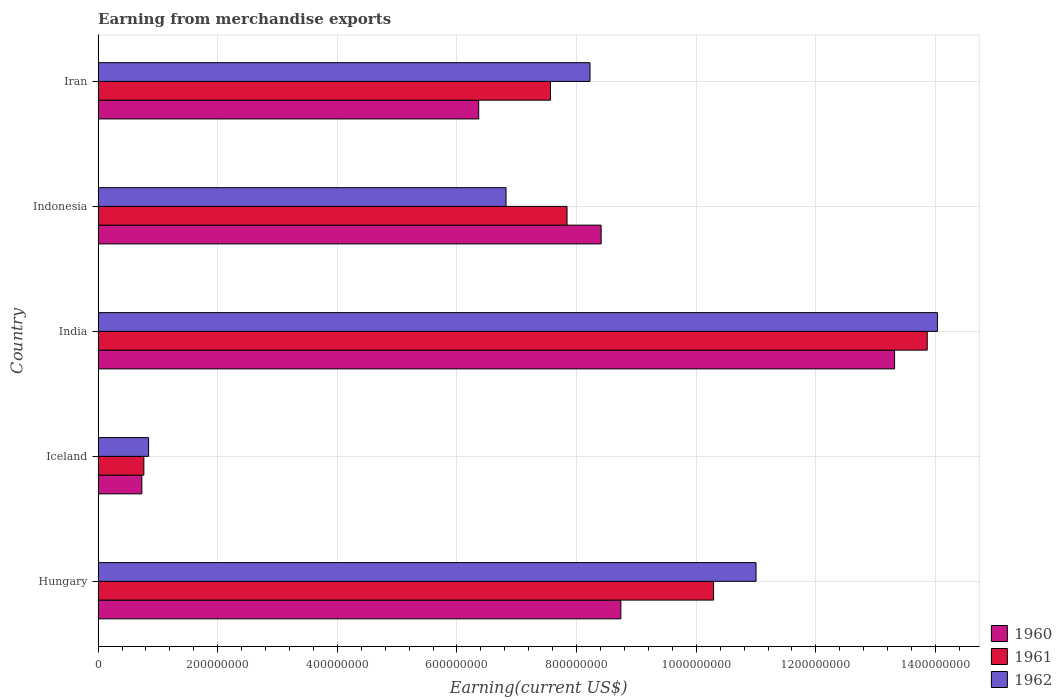Are the number of bars per tick equal to the number of legend labels?
Provide a short and direct response. Yes. How many bars are there on the 1st tick from the top?
Your answer should be very brief. 3. How many bars are there on the 5th tick from the bottom?
Provide a succinct answer. 3. What is the label of the 2nd group of bars from the top?
Your answer should be very brief. Indonesia. In how many cases, is the number of bars for a given country not equal to the number of legend labels?
Keep it short and to the point. 0. What is the amount earned from merchandise exports in 1962 in Hungary?
Your answer should be very brief. 1.10e+09. Across all countries, what is the maximum amount earned from merchandise exports in 1961?
Your response must be concise. 1.39e+09. Across all countries, what is the minimum amount earned from merchandise exports in 1960?
Provide a succinct answer. 7.31e+07. In which country was the amount earned from merchandise exports in 1961 maximum?
Your answer should be very brief. India. In which country was the amount earned from merchandise exports in 1961 minimum?
Give a very brief answer. Iceland. What is the total amount earned from merchandise exports in 1960 in the graph?
Keep it short and to the point. 3.76e+09. What is the difference between the amount earned from merchandise exports in 1961 in India and that in Iran?
Ensure brevity in your answer.  6.30e+08. What is the difference between the amount earned from merchandise exports in 1960 in Indonesia and the amount earned from merchandise exports in 1961 in Hungary?
Your response must be concise. -1.88e+08. What is the average amount earned from merchandise exports in 1961 per country?
Make the answer very short. 8.06e+08. What is the difference between the amount earned from merchandise exports in 1962 and amount earned from merchandise exports in 1960 in Iran?
Ensure brevity in your answer.  1.86e+08. What is the ratio of the amount earned from merchandise exports in 1962 in India to that in Indonesia?
Your answer should be compact. 2.06. What is the difference between the highest and the second highest amount earned from merchandise exports in 1960?
Your response must be concise. 4.58e+08. What is the difference between the highest and the lowest amount earned from merchandise exports in 1960?
Offer a very short reply. 1.26e+09. In how many countries, is the amount earned from merchandise exports in 1961 greater than the average amount earned from merchandise exports in 1961 taken over all countries?
Your answer should be compact. 2. Is the sum of the amount earned from merchandise exports in 1961 in Iceland and India greater than the maximum amount earned from merchandise exports in 1962 across all countries?
Provide a short and direct response. Yes. How many bars are there?
Your response must be concise. 15. Are all the bars in the graph horizontal?
Make the answer very short. Yes. How many countries are there in the graph?
Provide a short and direct response. 5. What is the difference between two consecutive major ticks on the X-axis?
Offer a terse response. 2.00e+08. Are the values on the major ticks of X-axis written in scientific E-notation?
Your answer should be compact. No. Does the graph contain grids?
Your answer should be very brief. Yes. Where does the legend appear in the graph?
Make the answer very short. Bottom right. How are the legend labels stacked?
Ensure brevity in your answer.  Vertical. What is the title of the graph?
Your answer should be compact. Earning from merchandise exports. What is the label or title of the X-axis?
Your response must be concise. Earning(current US$). What is the label or title of the Y-axis?
Offer a terse response. Country. What is the Earning(current US$) in 1960 in Hungary?
Provide a short and direct response. 8.74e+08. What is the Earning(current US$) of 1961 in Hungary?
Your answer should be very brief. 1.03e+09. What is the Earning(current US$) in 1962 in Hungary?
Provide a short and direct response. 1.10e+09. What is the Earning(current US$) of 1960 in Iceland?
Offer a very short reply. 7.31e+07. What is the Earning(current US$) in 1961 in Iceland?
Provide a succinct answer. 7.65e+07. What is the Earning(current US$) in 1962 in Iceland?
Offer a terse response. 8.44e+07. What is the Earning(current US$) of 1960 in India?
Ensure brevity in your answer.  1.33e+09. What is the Earning(current US$) of 1961 in India?
Your answer should be very brief. 1.39e+09. What is the Earning(current US$) in 1962 in India?
Offer a very short reply. 1.40e+09. What is the Earning(current US$) of 1960 in Indonesia?
Provide a succinct answer. 8.41e+08. What is the Earning(current US$) in 1961 in Indonesia?
Provide a succinct answer. 7.84e+08. What is the Earning(current US$) of 1962 in Indonesia?
Give a very brief answer. 6.82e+08. What is the Earning(current US$) of 1960 in Iran?
Offer a terse response. 6.36e+08. What is the Earning(current US$) in 1961 in Iran?
Ensure brevity in your answer.  7.56e+08. What is the Earning(current US$) of 1962 in Iran?
Your answer should be very brief. 8.22e+08. Across all countries, what is the maximum Earning(current US$) of 1960?
Provide a succinct answer. 1.33e+09. Across all countries, what is the maximum Earning(current US$) of 1961?
Ensure brevity in your answer.  1.39e+09. Across all countries, what is the maximum Earning(current US$) of 1962?
Offer a very short reply. 1.40e+09. Across all countries, what is the minimum Earning(current US$) in 1960?
Your answer should be compact. 7.31e+07. Across all countries, what is the minimum Earning(current US$) of 1961?
Make the answer very short. 7.65e+07. Across all countries, what is the minimum Earning(current US$) of 1962?
Your response must be concise. 8.44e+07. What is the total Earning(current US$) in 1960 in the graph?
Offer a terse response. 3.76e+09. What is the total Earning(current US$) in 1961 in the graph?
Your response must be concise. 4.03e+09. What is the total Earning(current US$) of 1962 in the graph?
Your answer should be compact. 4.09e+09. What is the difference between the Earning(current US$) in 1960 in Hungary and that in Iceland?
Offer a terse response. 8.01e+08. What is the difference between the Earning(current US$) in 1961 in Hungary and that in Iceland?
Keep it short and to the point. 9.53e+08. What is the difference between the Earning(current US$) in 1962 in Hungary and that in Iceland?
Keep it short and to the point. 1.02e+09. What is the difference between the Earning(current US$) in 1960 in Hungary and that in India?
Provide a short and direct response. -4.58e+08. What is the difference between the Earning(current US$) of 1961 in Hungary and that in India?
Provide a short and direct response. -3.57e+08. What is the difference between the Earning(current US$) in 1962 in Hungary and that in India?
Give a very brief answer. -3.03e+08. What is the difference between the Earning(current US$) of 1960 in Hungary and that in Indonesia?
Keep it short and to the point. 3.30e+07. What is the difference between the Earning(current US$) of 1961 in Hungary and that in Indonesia?
Your response must be concise. 2.45e+08. What is the difference between the Earning(current US$) in 1962 in Hungary and that in Indonesia?
Make the answer very short. 4.18e+08. What is the difference between the Earning(current US$) in 1960 in Hungary and that in Iran?
Offer a terse response. 2.38e+08. What is the difference between the Earning(current US$) of 1961 in Hungary and that in Iran?
Provide a succinct answer. 2.73e+08. What is the difference between the Earning(current US$) of 1962 in Hungary and that in Iran?
Give a very brief answer. 2.78e+08. What is the difference between the Earning(current US$) in 1960 in Iceland and that in India?
Provide a succinct answer. -1.26e+09. What is the difference between the Earning(current US$) in 1961 in Iceland and that in India?
Ensure brevity in your answer.  -1.31e+09. What is the difference between the Earning(current US$) in 1962 in Iceland and that in India?
Your answer should be very brief. -1.32e+09. What is the difference between the Earning(current US$) in 1960 in Iceland and that in Indonesia?
Make the answer very short. -7.68e+08. What is the difference between the Earning(current US$) in 1961 in Iceland and that in Indonesia?
Provide a short and direct response. -7.08e+08. What is the difference between the Earning(current US$) in 1962 in Iceland and that in Indonesia?
Give a very brief answer. -5.98e+08. What is the difference between the Earning(current US$) of 1960 in Iceland and that in Iran?
Give a very brief answer. -5.63e+08. What is the difference between the Earning(current US$) of 1961 in Iceland and that in Iran?
Offer a very short reply. -6.80e+08. What is the difference between the Earning(current US$) of 1962 in Iceland and that in Iran?
Ensure brevity in your answer.  -7.38e+08. What is the difference between the Earning(current US$) in 1960 in India and that in Indonesia?
Your answer should be very brief. 4.91e+08. What is the difference between the Earning(current US$) of 1961 in India and that in Indonesia?
Keep it short and to the point. 6.02e+08. What is the difference between the Earning(current US$) of 1962 in India and that in Indonesia?
Provide a short and direct response. 7.21e+08. What is the difference between the Earning(current US$) of 1960 in India and that in Iran?
Provide a short and direct response. 6.95e+08. What is the difference between the Earning(current US$) of 1961 in India and that in Iran?
Your answer should be compact. 6.30e+08. What is the difference between the Earning(current US$) of 1962 in India and that in Iran?
Keep it short and to the point. 5.81e+08. What is the difference between the Earning(current US$) of 1960 in Indonesia and that in Iran?
Ensure brevity in your answer.  2.05e+08. What is the difference between the Earning(current US$) in 1961 in Indonesia and that in Iran?
Your answer should be very brief. 2.77e+07. What is the difference between the Earning(current US$) of 1962 in Indonesia and that in Iran?
Offer a terse response. -1.40e+08. What is the difference between the Earning(current US$) of 1960 in Hungary and the Earning(current US$) of 1961 in Iceland?
Your answer should be very brief. 7.98e+08. What is the difference between the Earning(current US$) in 1960 in Hungary and the Earning(current US$) in 1962 in Iceland?
Provide a short and direct response. 7.90e+08. What is the difference between the Earning(current US$) in 1961 in Hungary and the Earning(current US$) in 1962 in Iceland?
Offer a terse response. 9.45e+08. What is the difference between the Earning(current US$) of 1960 in Hungary and the Earning(current US$) of 1961 in India?
Give a very brief answer. -5.12e+08. What is the difference between the Earning(current US$) in 1960 in Hungary and the Earning(current US$) in 1962 in India?
Your answer should be very brief. -5.29e+08. What is the difference between the Earning(current US$) of 1961 in Hungary and the Earning(current US$) of 1962 in India?
Offer a very short reply. -3.74e+08. What is the difference between the Earning(current US$) of 1960 in Hungary and the Earning(current US$) of 1961 in Indonesia?
Give a very brief answer. 9.00e+07. What is the difference between the Earning(current US$) of 1960 in Hungary and the Earning(current US$) of 1962 in Indonesia?
Provide a short and direct response. 1.92e+08. What is the difference between the Earning(current US$) in 1961 in Hungary and the Earning(current US$) in 1962 in Indonesia?
Offer a very short reply. 3.47e+08. What is the difference between the Earning(current US$) of 1960 in Hungary and the Earning(current US$) of 1961 in Iran?
Give a very brief answer. 1.18e+08. What is the difference between the Earning(current US$) of 1960 in Hungary and the Earning(current US$) of 1962 in Iran?
Keep it short and to the point. 5.16e+07. What is the difference between the Earning(current US$) of 1961 in Hungary and the Earning(current US$) of 1962 in Iran?
Offer a terse response. 2.07e+08. What is the difference between the Earning(current US$) of 1960 in Iceland and the Earning(current US$) of 1961 in India?
Your answer should be compact. -1.31e+09. What is the difference between the Earning(current US$) in 1960 in Iceland and the Earning(current US$) in 1962 in India?
Your response must be concise. -1.33e+09. What is the difference between the Earning(current US$) of 1961 in Iceland and the Earning(current US$) of 1962 in India?
Offer a very short reply. -1.33e+09. What is the difference between the Earning(current US$) of 1960 in Iceland and the Earning(current US$) of 1961 in Indonesia?
Ensure brevity in your answer.  -7.11e+08. What is the difference between the Earning(current US$) of 1960 in Iceland and the Earning(current US$) of 1962 in Indonesia?
Offer a very short reply. -6.09e+08. What is the difference between the Earning(current US$) of 1961 in Iceland and the Earning(current US$) of 1962 in Indonesia?
Your response must be concise. -6.06e+08. What is the difference between the Earning(current US$) in 1960 in Iceland and the Earning(current US$) in 1961 in Iran?
Offer a terse response. -6.83e+08. What is the difference between the Earning(current US$) in 1960 in Iceland and the Earning(current US$) in 1962 in Iran?
Your response must be concise. -7.49e+08. What is the difference between the Earning(current US$) in 1961 in Iceland and the Earning(current US$) in 1962 in Iran?
Make the answer very short. -7.46e+08. What is the difference between the Earning(current US$) in 1960 in India and the Earning(current US$) in 1961 in Indonesia?
Provide a short and direct response. 5.48e+08. What is the difference between the Earning(current US$) in 1960 in India and the Earning(current US$) in 1962 in Indonesia?
Keep it short and to the point. 6.50e+08. What is the difference between the Earning(current US$) in 1961 in India and the Earning(current US$) in 1962 in Indonesia?
Ensure brevity in your answer.  7.04e+08. What is the difference between the Earning(current US$) in 1960 in India and the Earning(current US$) in 1961 in Iran?
Provide a short and direct response. 5.75e+08. What is the difference between the Earning(current US$) of 1960 in India and the Earning(current US$) of 1962 in Iran?
Ensure brevity in your answer.  5.09e+08. What is the difference between the Earning(current US$) in 1961 in India and the Earning(current US$) in 1962 in Iran?
Offer a terse response. 5.64e+08. What is the difference between the Earning(current US$) of 1960 in Indonesia and the Earning(current US$) of 1961 in Iran?
Your answer should be compact. 8.47e+07. What is the difference between the Earning(current US$) in 1960 in Indonesia and the Earning(current US$) in 1962 in Iran?
Offer a terse response. 1.86e+07. What is the difference between the Earning(current US$) in 1961 in Indonesia and the Earning(current US$) in 1962 in Iran?
Offer a terse response. -3.84e+07. What is the average Earning(current US$) in 1960 per country?
Make the answer very short. 7.51e+08. What is the average Earning(current US$) of 1961 per country?
Ensure brevity in your answer.  8.06e+08. What is the average Earning(current US$) in 1962 per country?
Provide a succinct answer. 8.18e+08. What is the difference between the Earning(current US$) of 1960 and Earning(current US$) of 1961 in Hungary?
Your answer should be very brief. -1.55e+08. What is the difference between the Earning(current US$) of 1960 and Earning(current US$) of 1962 in Hungary?
Your response must be concise. -2.26e+08. What is the difference between the Earning(current US$) in 1961 and Earning(current US$) in 1962 in Hungary?
Provide a short and direct response. -7.10e+07. What is the difference between the Earning(current US$) of 1960 and Earning(current US$) of 1961 in Iceland?
Ensure brevity in your answer.  -3.37e+06. What is the difference between the Earning(current US$) in 1960 and Earning(current US$) in 1962 in Iceland?
Give a very brief answer. -1.13e+07. What is the difference between the Earning(current US$) of 1961 and Earning(current US$) of 1962 in Iceland?
Keep it short and to the point. -7.94e+06. What is the difference between the Earning(current US$) of 1960 and Earning(current US$) of 1961 in India?
Your answer should be compact. -5.46e+07. What is the difference between the Earning(current US$) in 1960 and Earning(current US$) in 1962 in India?
Ensure brevity in your answer.  -7.16e+07. What is the difference between the Earning(current US$) in 1961 and Earning(current US$) in 1962 in India?
Your response must be concise. -1.70e+07. What is the difference between the Earning(current US$) of 1960 and Earning(current US$) of 1961 in Indonesia?
Your response must be concise. 5.70e+07. What is the difference between the Earning(current US$) of 1960 and Earning(current US$) of 1962 in Indonesia?
Your response must be concise. 1.59e+08. What is the difference between the Earning(current US$) in 1961 and Earning(current US$) in 1962 in Indonesia?
Offer a very short reply. 1.02e+08. What is the difference between the Earning(current US$) in 1960 and Earning(current US$) in 1961 in Iran?
Your response must be concise. -1.20e+08. What is the difference between the Earning(current US$) in 1960 and Earning(current US$) in 1962 in Iran?
Offer a very short reply. -1.86e+08. What is the difference between the Earning(current US$) in 1961 and Earning(current US$) in 1962 in Iran?
Offer a very short reply. -6.61e+07. What is the ratio of the Earning(current US$) in 1960 in Hungary to that in Iceland?
Offer a very short reply. 11.95. What is the ratio of the Earning(current US$) in 1961 in Hungary to that in Iceland?
Make the answer very short. 13.45. What is the ratio of the Earning(current US$) of 1962 in Hungary to that in Iceland?
Offer a very short reply. 13.03. What is the ratio of the Earning(current US$) in 1960 in Hungary to that in India?
Keep it short and to the point. 0.66. What is the ratio of the Earning(current US$) of 1961 in Hungary to that in India?
Provide a succinct answer. 0.74. What is the ratio of the Earning(current US$) of 1962 in Hungary to that in India?
Your response must be concise. 0.78. What is the ratio of the Earning(current US$) in 1960 in Hungary to that in Indonesia?
Keep it short and to the point. 1.04. What is the ratio of the Earning(current US$) in 1961 in Hungary to that in Indonesia?
Ensure brevity in your answer.  1.31. What is the ratio of the Earning(current US$) in 1962 in Hungary to that in Indonesia?
Your answer should be very brief. 1.61. What is the ratio of the Earning(current US$) of 1960 in Hungary to that in Iran?
Give a very brief answer. 1.37. What is the ratio of the Earning(current US$) in 1961 in Hungary to that in Iran?
Give a very brief answer. 1.36. What is the ratio of the Earning(current US$) of 1962 in Hungary to that in Iran?
Your answer should be very brief. 1.34. What is the ratio of the Earning(current US$) of 1960 in Iceland to that in India?
Offer a terse response. 0.05. What is the ratio of the Earning(current US$) of 1961 in Iceland to that in India?
Provide a short and direct response. 0.06. What is the ratio of the Earning(current US$) of 1962 in Iceland to that in India?
Your answer should be compact. 0.06. What is the ratio of the Earning(current US$) of 1960 in Iceland to that in Indonesia?
Offer a terse response. 0.09. What is the ratio of the Earning(current US$) of 1961 in Iceland to that in Indonesia?
Ensure brevity in your answer.  0.1. What is the ratio of the Earning(current US$) in 1962 in Iceland to that in Indonesia?
Your response must be concise. 0.12. What is the ratio of the Earning(current US$) in 1960 in Iceland to that in Iran?
Your answer should be very brief. 0.11. What is the ratio of the Earning(current US$) of 1961 in Iceland to that in Iran?
Your answer should be compact. 0.1. What is the ratio of the Earning(current US$) of 1962 in Iceland to that in Iran?
Provide a short and direct response. 0.1. What is the ratio of the Earning(current US$) in 1960 in India to that in Indonesia?
Ensure brevity in your answer.  1.58. What is the ratio of the Earning(current US$) of 1961 in India to that in Indonesia?
Give a very brief answer. 1.77. What is the ratio of the Earning(current US$) of 1962 in India to that in Indonesia?
Give a very brief answer. 2.06. What is the ratio of the Earning(current US$) of 1960 in India to that in Iran?
Your response must be concise. 2.09. What is the ratio of the Earning(current US$) of 1961 in India to that in Iran?
Your answer should be compact. 1.83. What is the ratio of the Earning(current US$) in 1962 in India to that in Iran?
Your response must be concise. 1.71. What is the ratio of the Earning(current US$) of 1960 in Indonesia to that in Iran?
Your response must be concise. 1.32. What is the ratio of the Earning(current US$) in 1961 in Indonesia to that in Iran?
Your answer should be compact. 1.04. What is the ratio of the Earning(current US$) of 1962 in Indonesia to that in Iran?
Your answer should be very brief. 0.83. What is the difference between the highest and the second highest Earning(current US$) of 1960?
Give a very brief answer. 4.58e+08. What is the difference between the highest and the second highest Earning(current US$) of 1961?
Offer a very short reply. 3.57e+08. What is the difference between the highest and the second highest Earning(current US$) of 1962?
Your answer should be very brief. 3.03e+08. What is the difference between the highest and the lowest Earning(current US$) of 1960?
Give a very brief answer. 1.26e+09. What is the difference between the highest and the lowest Earning(current US$) of 1961?
Offer a terse response. 1.31e+09. What is the difference between the highest and the lowest Earning(current US$) of 1962?
Your response must be concise. 1.32e+09. 